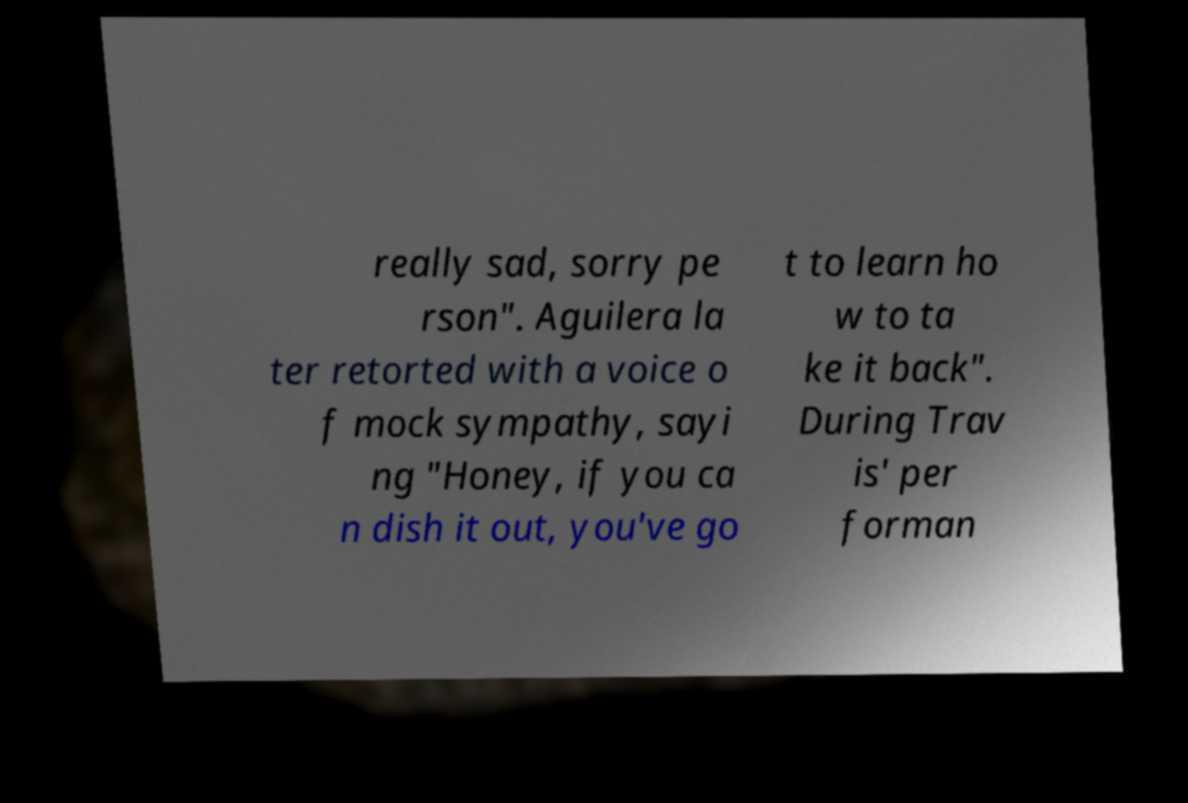I need the written content from this picture converted into text. Can you do that? really sad, sorry pe rson". Aguilera la ter retorted with a voice o f mock sympathy, sayi ng "Honey, if you ca n dish it out, you've go t to learn ho w to ta ke it back". During Trav is' per forman 